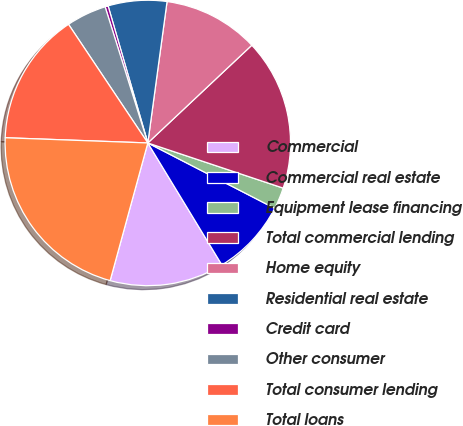Convert chart. <chart><loc_0><loc_0><loc_500><loc_500><pie_chart><fcel>Commercial<fcel>Commercial real estate<fcel>Equipment lease financing<fcel>Total commercial lending<fcel>Home equity<fcel>Residential real estate<fcel>Credit card<fcel>Other consumer<fcel>Total consumer lending<fcel>Total loans<nl><fcel>12.94%<fcel>8.74%<fcel>2.45%<fcel>17.13%<fcel>10.84%<fcel>6.64%<fcel>0.35%<fcel>4.54%<fcel>15.04%<fcel>21.33%<nl></chart> 